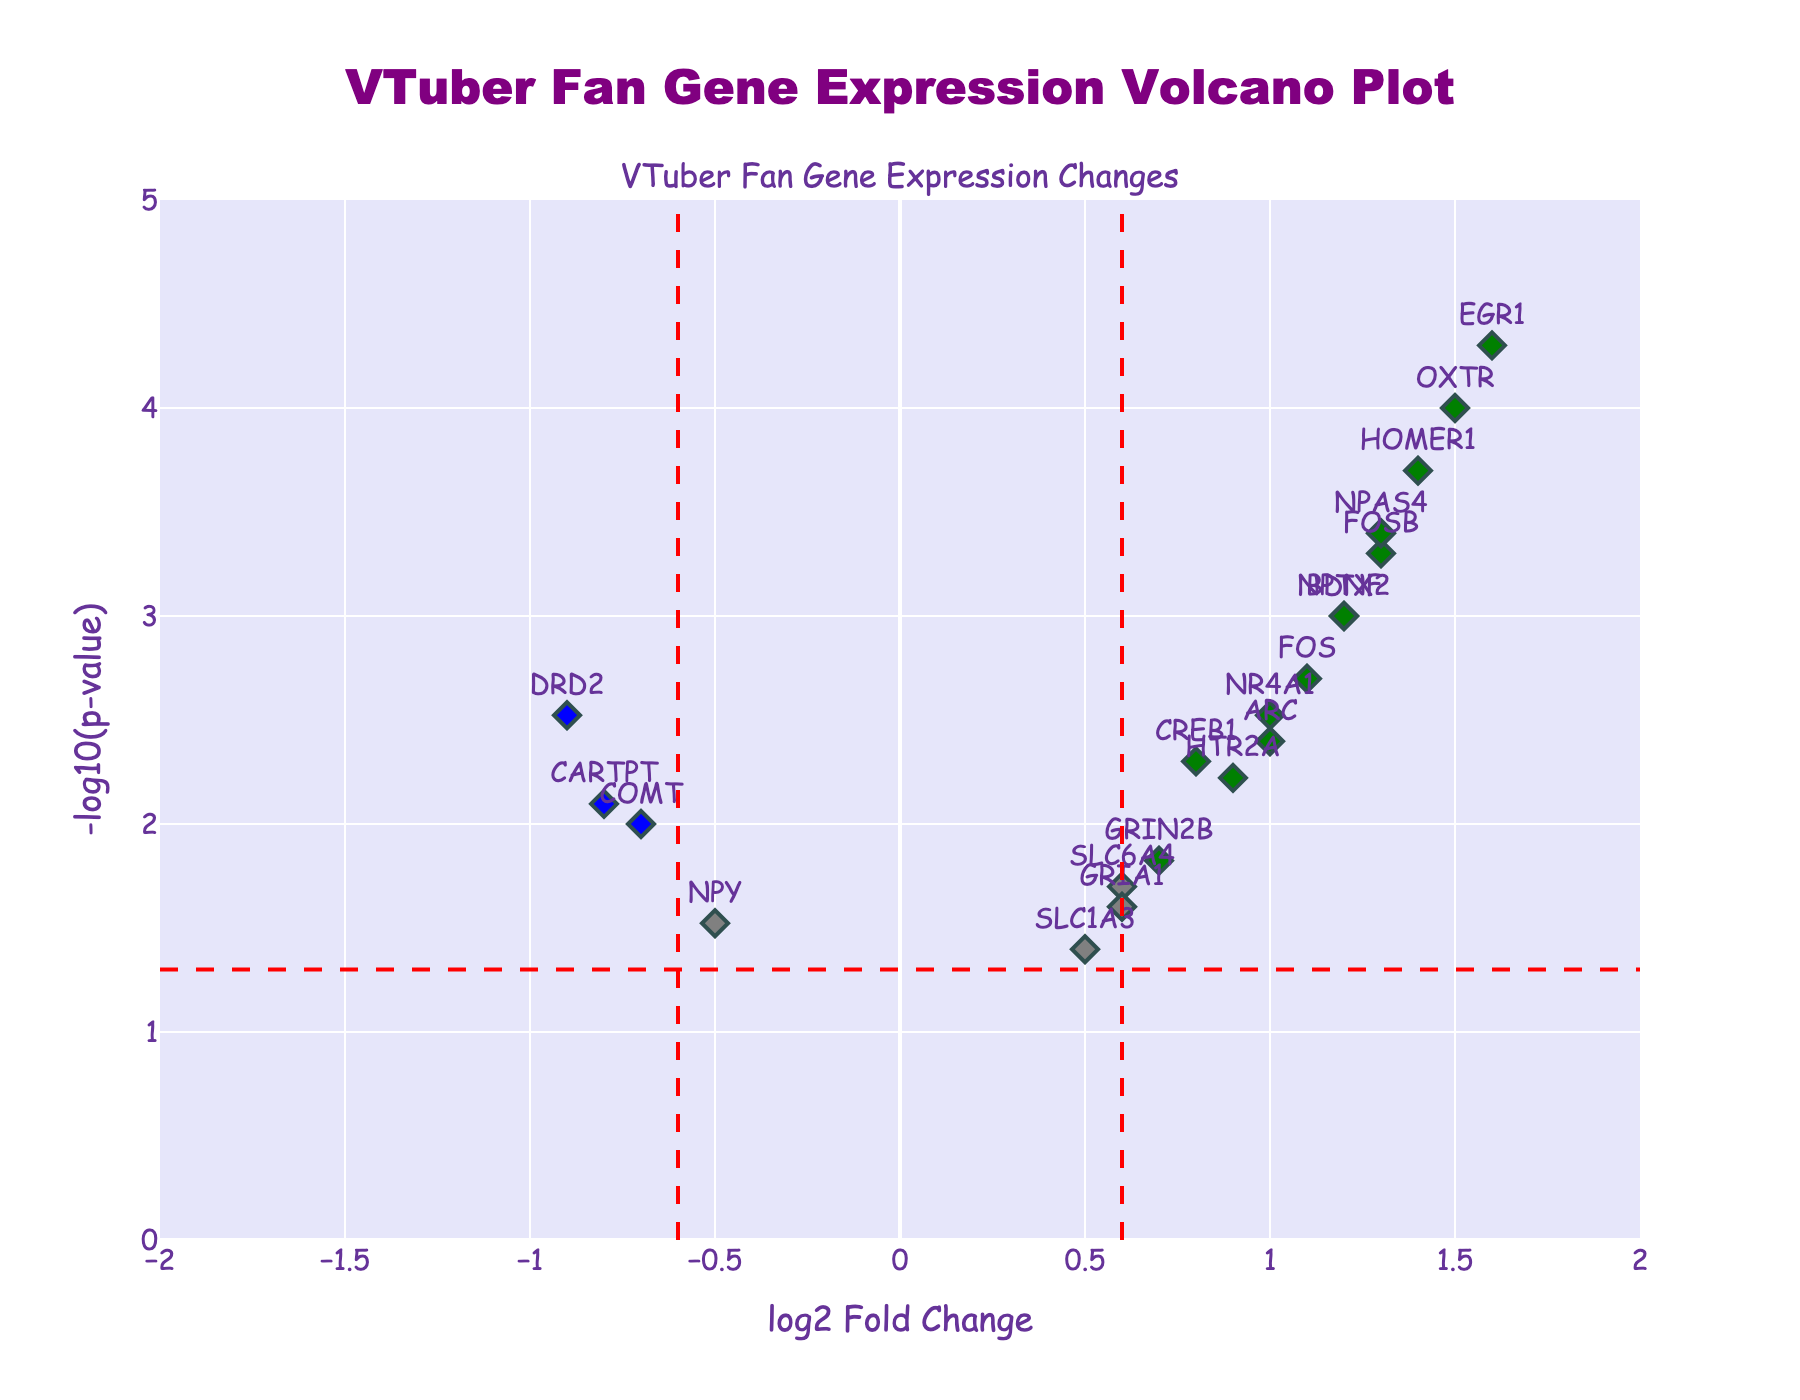What does the color coding in the plot represent? The plot uses color codes to indicate the significance of gene expression changes. Red points represent genes with significant positive changes (log2FoldChange > 0.6, p-value < 0.05), blue points represent genes with significant negative changes (log2FoldChange < -0.6, p-value < 0.05), and grey points represent non-significant changes.
Answer: Significant changes (red/blue) vs. non-significant changes (grey) What is the title of the plot? The title of the plot is displayed prominently at the top of the figure.
Answer: "VTuber Fan Gene Expression Volcano Plot" Which gene has the highest log2FoldChange? By observing the x-axis, we identify that the gene with the highest log2FoldChange value is the one furthest to the right.
Answer: EGR1 Which gene has the lowest p-value? The gene with the lowest p-value will be represented by the point with the highest -log10(p-value) on the y-axis.
Answer: EGR1 How many genes show significant up-regulation? Significant up-regulation is represented by points in green above the horizontal threshold line. Count the number of green points.
Answer: 13 What are the thresholds for log2FoldChange and p-value used in the plot? Vertical lines and the horizontal line in the plot indicate the thresholds. The log2FoldChange threshold is shown at ±0.6 on the x-axis, and the p-value threshold is -log10(0.05).
Answer: Log2FoldChange: ±0.6, p-value: 0.05 Which genes show log2FoldChange less than -0.6 and significant p-values? Genes with log2FoldChange less than -0.6 that also have p-values less than 0.05 are marked in blue. By inspecting these blue points, we identify the genes.
Answer: DRD2, COMT, CARTPT Which genes are both most up-regulated and most down-regulated based on log2FoldChange? The most up-regulated gene has the highest positive log2FoldChange, and the most down-regulated gene has the lowest negative log2FoldChange.
Answer: Most up-regulated: EGR1, Most down-regulated: DRD2 Are there any genes that are up-regulated x3 and also have a p-value smaller than 0.01? Identify genes that have log2FoldChange > 3 and p-value < 0.01. In this case, no genes exceed a log2FoldChange of 3.
Answer: No What are the coordinates (log2FoldChange and -log10(p-value)) of the HOMER1 gene? Find the point labeled 'HOMER1' in the plot and check its x and y coordinates.
Answer: (1.4, 3.699) How many genes have a -log10(p-value) greater than 1.301 and are represented in green? A -log10(p-value) of 1.301 corresponds to a p-value threshold of 0.05. Count the number of green points above this threshold.
Answer: 13 